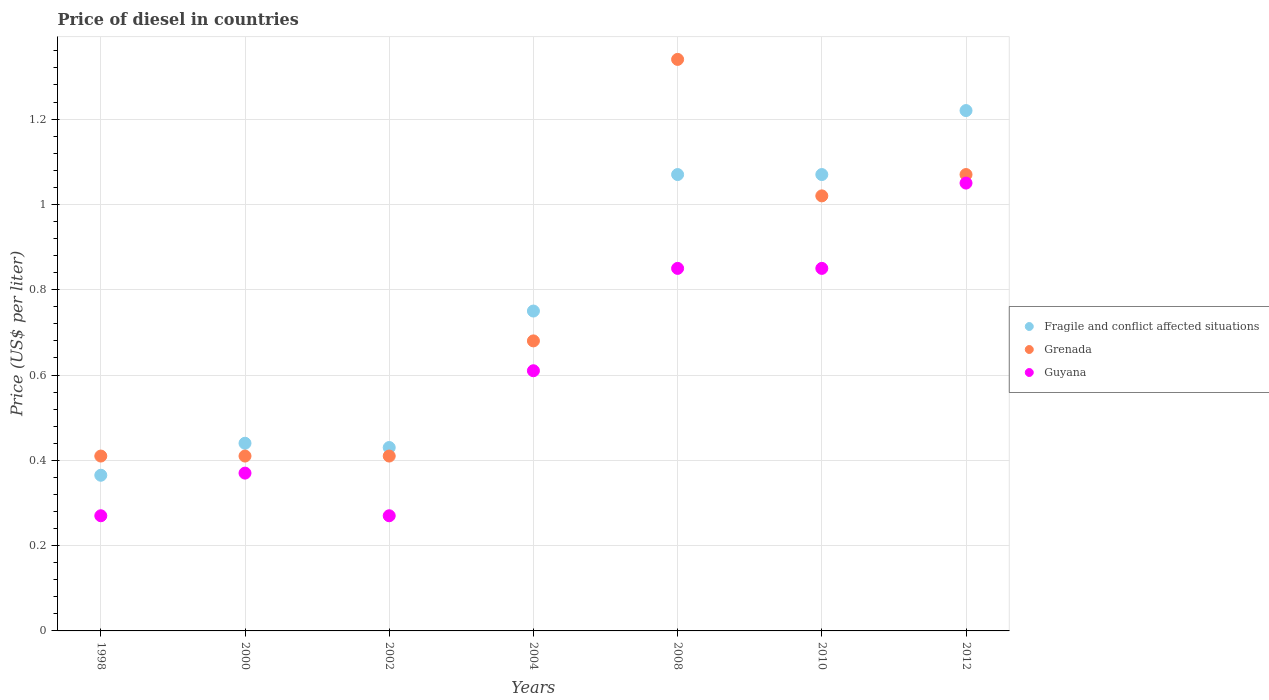Across all years, what is the minimum price of diesel in Guyana?
Provide a short and direct response. 0.27. What is the total price of diesel in Guyana in the graph?
Your response must be concise. 4.27. What is the difference between the price of diesel in Guyana in 2002 and that in 2012?
Keep it short and to the point. -0.78. What is the difference between the price of diesel in Guyana in 2000 and the price of diesel in Grenada in 2008?
Offer a very short reply. -0.97. What is the average price of diesel in Grenada per year?
Offer a very short reply. 0.76. In the year 2002, what is the difference between the price of diesel in Guyana and price of diesel in Fragile and conflict affected situations?
Offer a very short reply. -0.16. What is the ratio of the price of diesel in Fragile and conflict affected situations in 1998 to that in 2010?
Your response must be concise. 0.34. Is the difference between the price of diesel in Guyana in 1998 and 2012 greater than the difference between the price of diesel in Fragile and conflict affected situations in 1998 and 2012?
Your answer should be compact. Yes. What is the difference between the highest and the second highest price of diesel in Grenada?
Keep it short and to the point. 0.27. What is the difference between the highest and the lowest price of diesel in Fragile and conflict affected situations?
Make the answer very short. 0.85. In how many years, is the price of diesel in Grenada greater than the average price of diesel in Grenada taken over all years?
Offer a very short reply. 3. Is the sum of the price of diesel in Fragile and conflict affected situations in 2002 and 2012 greater than the maximum price of diesel in Guyana across all years?
Your answer should be compact. Yes. Is it the case that in every year, the sum of the price of diesel in Guyana and price of diesel in Fragile and conflict affected situations  is greater than the price of diesel in Grenada?
Your answer should be compact. Yes. Is the price of diesel in Fragile and conflict affected situations strictly less than the price of diesel in Guyana over the years?
Give a very brief answer. No. How many dotlines are there?
Give a very brief answer. 3. Are the values on the major ticks of Y-axis written in scientific E-notation?
Provide a succinct answer. No. Does the graph contain any zero values?
Provide a short and direct response. No. Does the graph contain grids?
Provide a succinct answer. Yes. Where does the legend appear in the graph?
Your answer should be very brief. Center right. How many legend labels are there?
Ensure brevity in your answer.  3. How are the legend labels stacked?
Your response must be concise. Vertical. What is the title of the graph?
Your answer should be very brief. Price of diesel in countries. What is the label or title of the X-axis?
Your answer should be compact. Years. What is the label or title of the Y-axis?
Your answer should be very brief. Price (US$ per liter). What is the Price (US$ per liter) of Fragile and conflict affected situations in 1998?
Ensure brevity in your answer.  0.36. What is the Price (US$ per liter) in Grenada in 1998?
Your answer should be very brief. 0.41. What is the Price (US$ per liter) in Guyana in 1998?
Offer a very short reply. 0.27. What is the Price (US$ per liter) in Fragile and conflict affected situations in 2000?
Ensure brevity in your answer.  0.44. What is the Price (US$ per liter) in Grenada in 2000?
Your answer should be very brief. 0.41. What is the Price (US$ per liter) of Guyana in 2000?
Your answer should be compact. 0.37. What is the Price (US$ per liter) of Fragile and conflict affected situations in 2002?
Make the answer very short. 0.43. What is the Price (US$ per liter) in Grenada in 2002?
Offer a very short reply. 0.41. What is the Price (US$ per liter) in Guyana in 2002?
Make the answer very short. 0.27. What is the Price (US$ per liter) in Fragile and conflict affected situations in 2004?
Your response must be concise. 0.75. What is the Price (US$ per liter) in Grenada in 2004?
Ensure brevity in your answer.  0.68. What is the Price (US$ per liter) in Guyana in 2004?
Provide a succinct answer. 0.61. What is the Price (US$ per liter) in Fragile and conflict affected situations in 2008?
Your answer should be compact. 1.07. What is the Price (US$ per liter) in Grenada in 2008?
Offer a terse response. 1.34. What is the Price (US$ per liter) of Guyana in 2008?
Keep it short and to the point. 0.85. What is the Price (US$ per liter) of Fragile and conflict affected situations in 2010?
Make the answer very short. 1.07. What is the Price (US$ per liter) in Grenada in 2010?
Offer a terse response. 1.02. What is the Price (US$ per liter) of Fragile and conflict affected situations in 2012?
Your answer should be compact. 1.22. What is the Price (US$ per liter) of Grenada in 2012?
Provide a short and direct response. 1.07. Across all years, what is the maximum Price (US$ per liter) of Fragile and conflict affected situations?
Give a very brief answer. 1.22. Across all years, what is the maximum Price (US$ per liter) of Grenada?
Ensure brevity in your answer.  1.34. Across all years, what is the maximum Price (US$ per liter) in Guyana?
Your response must be concise. 1.05. Across all years, what is the minimum Price (US$ per liter) of Fragile and conflict affected situations?
Your answer should be compact. 0.36. Across all years, what is the minimum Price (US$ per liter) of Grenada?
Your answer should be very brief. 0.41. Across all years, what is the minimum Price (US$ per liter) of Guyana?
Provide a succinct answer. 0.27. What is the total Price (US$ per liter) in Fragile and conflict affected situations in the graph?
Provide a short and direct response. 5.34. What is the total Price (US$ per liter) of Grenada in the graph?
Your answer should be compact. 5.34. What is the total Price (US$ per liter) of Guyana in the graph?
Keep it short and to the point. 4.27. What is the difference between the Price (US$ per liter) of Fragile and conflict affected situations in 1998 and that in 2000?
Offer a very short reply. -0.07. What is the difference between the Price (US$ per liter) of Guyana in 1998 and that in 2000?
Keep it short and to the point. -0.1. What is the difference between the Price (US$ per liter) of Fragile and conflict affected situations in 1998 and that in 2002?
Ensure brevity in your answer.  -0.07. What is the difference between the Price (US$ per liter) of Fragile and conflict affected situations in 1998 and that in 2004?
Give a very brief answer. -0.39. What is the difference between the Price (US$ per liter) of Grenada in 1998 and that in 2004?
Ensure brevity in your answer.  -0.27. What is the difference between the Price (US$ per liter) of Guyana in 1998 and that in 2004?
Provide a short and direct response. -0.34. What is the difference between the Price (US$ per liter) of Fragile and conflict affected situations in 1998 and that in 2008?
Ensure brevity in your answer.  -0.7. What is the difference between the Price (US$ per liter) in Grenada in 1998 and that in 2008?
Offer a very short reply. -0.93. What is the difference between the Price (US$ per liter) of Guyana in 1998 and that in 2008?
Your answer should be compact. -0.58. What is the difference between the Price (US$ per liter) of Fragile and conflict affected situations in 1998 and that in 2010?
Your response must be concise. -0.7. What is the difference between the Price (US$ per liter) of Grenada in 1998 and that in 2010?
Ensure brevity in your answer.  -0.61. What is the difference between the Price (US$ per liter) in Guyana in 1998 and that in 2010?
Provide a succinct answer. -0.58. What is the difference between the Price (US$ per liter) of Fragile and conflict affected situations in 1998 and that in 2012?
Your answer should be compact. -0.85. What is the difference between the Price (US$ per liter) of Grenada in 1998 and that in 2012?
Keep it short and to the point. -0.66. What is the difference between the Price (US$ per liter) in Guyana in 1998 and that in 2012?
Give a very brief answer. -0.78. What is the difference between the Price (US$ per liter) in Fragile and conflict affected situations in 2000 and that in 2002?
Ensure brevity in your answer.  0.01. What is the difference between the Price (US$ per liter) in Guyana in 2000 and that in 2002?
Your answer should be compact. 0.1. What is the difference between the Price (US$ per liter) of Fragile and conflict affected situations in 2000 and that in 2004?
Offer a very short reply. -0.31. What is the difference between the Price (US$ per liter) in Grenada in 2000 and that in 2004?
Ensure brevity in your answer.  -0.27. What is the difference between the Price (US$ per liter) of Guyana in 2000 and that in 2004?
Your answer should be very brief. -0.24. What is the difference between the Price (US$ per liter) of Fragile and conflict affected situations in 2000 and that in 2008?
Give a very brief answer. -0.63. What is the difference between the Price (US$ per liter) of Grenada in 2000 and that in 2008?
Give a very brief answer. -0.93. What is the difference between the Price (US$ per liter) in Guyana in 2000 and that in 2008?
Your answer should be compact. -0.48. What is the difference between the Price (US$ per liter) of Fragile and conflict affected situations in 2000 and that in 2010?
Offer a terse response. -0.63. What is the difference between the Price (US$ per liter) in Grenada in 2000 and that in 2010?
Ensure brevity in your answer.  -0.61. What is the difference between the Price (US$ per liter) in Guyana in 2000 and that in 2010?
Keep it short and to the point. -0.48. What is the difference between the Price (US$ per liter) in Fragile and conflict affected situations in 2000 and that in 2012?
Your answer should be compact. -0.78. What is the difference between the Price (US$ per liter) in Grenada in 2000 and that in 2012?
Provide a succinct answer. -0.66. What is the difference between the Price (US$ per liter) of Guyana in 2000 and that in 2012?
Provide a short and direct response. -0.68. What is the difference between the Price (US$ per liter) in Fragile and conflict affected situations in 2002 and that in 2004?
Provide a succinct answer. -0.32. What is the difference between the Price (US$ per liter) of Grenada in 2002 and that in 2004?
Your response must be concise. -0.27. What is the difference between the Price (US$ per liter) of Guyana in 2002 and that in 2004?
Offer a very short reply. -0.34. What is the difference between the Price (US$ per liter) in Fragile and conflict affected situations in 2002 and that in 2008?
Ensure brevity in your answer.  -0.64. What is the difference between the Price (US$ per liter) of Grenada in 2002 and that in 2008?
Keep it short and to the point. -0.93. What is the difference between the Price (US$ per liter) in Guyana in 2002 and that in 2008?
Offer a very short reply. -0.58. What is the difference between the Price (US$ per liter) of Fragile and conflict affected situations in 2002 and that in 2010?
Make the answer very short. -0.64. What is the difference between the Price (US$ per liter) of Grenada in 2002 and that in 2010?
Your response must be concise. -0.61. What is the difference between the Price (US$ per liter) in Guyana in 2002 and that in 2010?
Your response must be concise. -0.58. What is the difference between the Price (US$ per liter) in Fragile and conflict affected situations in 2002 and that in 2012?
Provide a succinct answer. -0.79. What is the difference between the Price (US$ per liter) in Grenada in 2002 and that in 2012?
Give a very brief answer. -0.66. What is the difference between the Price (US$ per liter) of Guyana in 2002 and that in 2012?
Provide a short and direct response. -0.78. What is the difference between the Price (US$ per liter) in Fragile and conflict affected situations in 2004 and that in 2008?
Provide a succinct answer. -0.32. What is the difference between the Price (US$ per liter) in Grenada in 2004 and that in 2008?
Give a very brief answer. -0.66. What is the difference between the Price (US$ per liter) in Guyana in 2004 and that in 2008?
Make the answer very short. -0.24. What is the difference between the Price (US$ per liter) in Fragile and conflict affected situations in 2004 and that in 2010?
Make the answer very short. -0.32. What is the difference between the Price (US$ per liter) in Grenada in 2004 and that in 2010?
Offer a terse response. -0.34. What is the difference between the Price (US$ per liter) in Guyana in 2004 and that in 2010?
Keep it short and to the point. -0.24. What is the difference between the Price (US$ per liter) of Fragile and conflict affected situations in 2004 and that in 2012?
Offer a terse response. -0.47. What is the difference between the Price (US$ per liter) of Grenada in 2004 and that in 2012?
Make the answer very short. -0.39. What is the difference between the Price (US$ per liter) in Guyana in 2004 and that in 2012?
Your answer should be very brief. -0.44. What is the difference between the Price (US$ per liter) of Fragile and conflict affected situations in 2008 and that in 2010?
Provide a short and direct response. 0. What is the difference between the Price (US$ per liter) of Grenada in 2008 and that in 2010?
Make the answer very short. 0.32. What is the difference between the Price (US$ per liter) in Fragile and conflict affected situations in 2008 and that in 2012?
Make the answer very short. -0.15. What is the difference between the Price (US$ per liter) of Grenada in 2008 and that in 2012?
Ensure brevity in your answer.  0.27. What is the difference between the Price (US$ per liter) in Guyana in 2008 and that in 2012?
Your answer should be very brief. -0.2. What is the difference between the Price (US$ per liter) of Grenada in 2010 and that in 2012?
Provide a succinct answer. -0.05. What is the difference between the Price (US$ per liter) in Fragile and conflict affected situations in 1998 and the Price (US$ per liter) in Grenada in 2000?
Provide a short and direct response. -0.04. What is the difference between the Price (US$ per liter) of Fragile and conflict affected situations in 1998 and the Price (US$ per liter) of Guyana in 2000?
Provide a short and direct response. -0.01. What is the difference between the Price (US$ per liter) of Fragile and conflict affected situations in 1998 and the Price (US$ per liter) of Grenada in 2002?
Your answer should be very brief. -0.04. What is the difference between the Price (US$ per liter) of Fragile and conflict affected situations in 1998 and the Price (US$ per liter) of Guyana in 2002?
Your answer should be very brief. 0.1. What is the difference between the Price (US$ per liter) of Grenada in 1998 and the Price (US$ per liter) of Guyana in 2002?
Ensure brevity in your answer.  0.14. What is the difference between the Price (US$ per liter) in Fragile and conflict affected situations in 1998 and the Price (US$ per liter) in Grenada in 2004?
Make the answer very short. -0.32. What is the difference between the Price (US$ per liter) in Fragile and conflict affected situations in 1998 and the Price (US$ per liter) in Guyana in 2004?
Provide a succinct answer. -0.24. What is the difference between the Price (US$ per liter) in Grenada in 1998 and the Price (US$ per liter) in Guyana in 2004?
Offer a terse response. -0.2. What is the difference between the Price (US$ per liter) of Fragile and conflict affected situations in 1998 and the Price (US$ per liter) of Grenada in 2008?
Your answer should be compact. -0.97. What is the difference between the Price (US$ per liter) of Fragile and conflict affected situations in 1998 and the Price (US$ per liter) of Guyana in 2008?
Your answer should be compact. -0.48. What is the difference between the Price (US$ per liter) of Grenada in 1998 and the Price (US$ per liter) of Guyana in 2008?
Provide a succinct answer. -0.44. What is the difference between the Price (US$ per liter) in Fragile and conflict affected situations in 1998 and the Price (US$ per liter) in Grenada in 2010?
Your answer should be compact. -0.66. What is the difference between the Price (US$ per liter) in Fragile and conflict affected situations in 1998 and the Price (US$ per liter) in Guyana in 2010?
Offer a very short reply. -0.48. What is the difference between the Price (US$ per liter) in Grenada in 1998 and the Price (US$ per liter) in Guyana in 2010?
Offer a very short reply. -0.44. What is the difference between the Price (US$ per liter) of Fragile and conflict affected situations in 1998 and the Price (US$ per liter) of Grenada in 2012?
Your response must be concise. -0.7. What is the difference between the Price (US$ per liter) of Fragile and conflict affected situations in 1998 and the Price (US$ per liter) of Guyana in 2012?
Your answer should be compact. -0.69. What is the difference between the Price (US$ per liter) of Grenada in 1998 and the Price (US$ per liter) of Guyana in 2012?
Make the answer very short. -0.64. What is the difference between the Price (US$ per liter) in Fragile and conflict affected situations in 2000 and the Price (US$ per liter) in Grenada in 2002?
Offer a terse response. 0.03. What is the difference between the Price (US$ per liter) of Fragile and conflict affected situations in 2000 and the Price (US$ per liter) of Guyana in 2002?
Keep it short and to the point. 0.17. What is the difference between the Price (US$ per liter) of Grenada in 2000 and the Price (US$ per liter) of Guyana in 2002?
Your response must be concise. 0.14. What is the difference between the Price (US$ per liter) in Fragile and conflict affected situations in 2000 and the Price (US$ per liter) in Grenada in 2004?
Your answer should be compact. -0.24. What is the difference between the Price (US$ per liter) in Fragile and conflict affected situations in 2000 and the Price (US$ per liter) in Guyana in 2004?
Your response must be concise. -0.17. What is the difference between the Price (US$ per liter) in Fragile and conflict affected situations in 2000 and the Price (US$ per liter) in Guyana in 2008?
Provide a succinct answer. -0.41. What is the difference between the Price (US$ per liter) of Grenada in 2000 and the Price (US$ per liter) of Guyana in 2008?
Your answer should be compact. -0.44. What is the difference between the Price (US$ per liter) of Fragile and conflict affected situations in 2000 and the Price (US$ per liter) of Grenada in 2010?
Your answer should be very brief. -0.58. What is the difference between the Price (US$ per liter) of Fragile and conflict affected situations in 2000 and the Price (US$ per liter) of Guyana in 2010?
Provide a succinct answer. -0.41. What is the difference between the Price (US$ per liter) of Grenada in 2000 and the Price (US$ per liter) of Guyana in 2010?
Give a very brief answer. -0.44. What is the difference between the Price (US$ per liter) of Fragile and conflict affected situations in 2000 and the Price (US$ per liter) of Grenada in 2012?
Your answer should be compact. -0.63. What is the difference between the Price (US$ per liter) in Fragile and conflict affected situations in 2000 and the Price (US$ per liter) in Guyana in 2012?
Provide a succinct answer. -0.61. What is the difference between the Price (US$ per liter) in Grenada in 2000 and the Price (US$ per liter) in Guyana in 2012?
Make the answer very short. -0.64. What is the difference between the Price (US$ per liter) of Fragile and conflict affected situations in 2002 and the Price (US$ per liter) of Guyana in 2004?
Make the answer very short. -0.18. What is the difference between the Price (US$ per liter) in Fragile and conflict affected situations in 2002 and the Price (US$ per liter) in Grenada in 2008?
Ensure brevity in your answer.  -0.91. What is the difference between the Price (US$ per liter) in Fragile and conflict affected situations in 2002 and the Price (US$ per liter) in Guyana in 2008?
Your answer should be very brief. -0.42. What is the difference between the Price (US$ per liter) of Grenada in 2002 and the Price (US$ per liter) of Guyana in 2008?
Your answer should be very brief. -0.44. What is the difference between the Price (US$ per liter) of Fragile and conflict affected situations in 2002 and the Price (US$ per liter) of Grenada in 2010?
Make the answer very short. -0.59. What is the difference between the Price (US$ per liter) in Fragile and conflict affected situations in 2002 and the Price (US$ per liter) in Guyana in 2010?
Give a very brief answer. -0.42. What is the difference between the Price (US$ per liter) in Grenada in 2002 and the Price (US$ per liter) in Guyana in 2010?
Keep it short and to the point. -0.44. What is the difference between the Price (US$ per liter) of Fragile and conflict affected situations in 2002 and the Price (US$ per liter) of Grenada in 2012?
Your response must be concise. -0.64. What is the difference between the Price (US$ per liter) in Fragile and conflict affected situations in 2002 and the Price (US$ per liter) in Guyana in 2012?
Offer a terse response. -0.62. What is the difference between the Price (US$ per liter) in Grenada in 2002 and the Price (US$ per liter) in Guyana in 2012?
Your answer should be compact. -0.64. What is the difference between the Price (US$ per liter) in Fragile and conflict affected situations in 2004 and the Price (US$ per liter) in Grenada in 2008?
Ensure brevity in your answer.  -0.59. What is the difference between the Price (US$ per liter) in Fragile and conflict affected situations in 2004 and the Price (US$ per liter) in Guyana in 2008?
Your response must be concise. -0.1. What is the difference between the Price (US$ per liter) of Grenada in 2004 and the Price (US$ per liter) of Guyana in 2008?
Your answer should be compact. -0.17. What is the difference between the Price (US$ per liter) in Fragile and conflict affected situations in 2004 and the Price (US$ per liter) in Grenada in 2010?
Keep it short and to the point. -0.27. What is the difference between the Price (US$ per liter) of Grenada in 2004 and the Price (US$ per liter) of Guyana in 2010?
Offer a very short reply. -0.17. What is the difference between the Price (US$ per liter) in Fragile and conflict affected situations in 2004 and the Price (US$ per liter) in Grenada in 2012?
Your response must be concise. -0.32. What is the difference between the Price (US$ per liter) in Grenada in 2004 and the Price (US$ per liter) in Guyana in 2012?
Ensure brevity in your answer.  -0.37. What is the difference between the Price (US$ per liter) in Fragile and conflict affected situations in 2008 and the Price (US$ per liter) in Grenada in 2010?
Make the answer very short. 0.05. What is the difference between the Price (US$ per liter) in Fragile and conflict affected situations in 2008 and the Price (US$ per liter) in Guyana in 2010?
Your answer should be very brief. 0.22. What is the difference between the Price (US$ per liter) of Grenada in 2008 and the Price (US$ per liter) of Guyana in 2010?
Give a very brief answer. 0.49. What is the difference between the Price (US$ per liter) in Grenada in 2008 and the Price (US$ per liter) in Guyana in 2012?
Your response must be concise. 0.29. What is the difference between the Price (US$ per liter) of Grenada in 2010 and the Price (US$ per liter) of Guyana in 2012?
Keep it short and to the point. -0.03. What is the average Price (US$ per liter) of Fragile and conflict affected situations per year?
Provide a short and direct response. 0.76. What is the average Price (US$ per liter) in Grenada per year?
Provide a short and direct response. 0.76. What is the average Price (US$ per liter) of Guyana per year?
Ensure brevity in your answer.  0.61. In the year 1998, what is the difference between the Price (US$ per liter) of Fragile and conflict affected situations and Price (US$ per liter) of Grenada?
Offer a terse response. -0.04. In the year 1998, what is the difference between the Price (US$ per liter) in Fragile and conflict affected situations and Price (US$ per liter) in Guyana?
Give a very brief answer. 0.1. In the year 1998, what is the difference between the Price (US$ per liter) of Grenada and Price (US$ per liter) of Guyana?
Offer a very short reply. 0.14. In the year 2000, what is the difference between the Price (US$ per liter) of Fragile and conflict affected situations and Price (US$ per liter) of Grenada?
Offer a terse response. 0.03. In the year 2000, what is the difference between the Price (US$ per liter) in Fragile and conflict affected situations and Price (US$ per liter) in Guyana?
Make the answer very short. 0.07. In the year 2000, what is the difference between the Price (US$ per liter) of Grenada and Price (US$ per liter) of Guyana?
Your answer should be very brief. 0.04. In the year 2002, what is the difference between the Price (US$ per liter) of Fragile and conflict affected situations and Price (US$ per liter) of Grenada?
Provide a short and direct response. 0.02. In the year 2002, what is the difference between the Price (US$ per liter) in Fragile and conflict affected situations and Price (US$ per liter) in Guyana?
Offer a very short reply. 0.16. In the year 2002, what is the difference between the Price (US$ per liter) in Grenada and Price (US$ per liter) in Guyana?
Provide a short and direct response. 0.14. In the year 2004, what is the difference between the Price (US$ per liter) in Fragile and conflict affected situations and Price (US$ per liter) in Grenada?
Provide a succinct answer. 0.07. In the year 2004, what is the difference between the Price (US$ per liter) in Fragile and conflict affected situations and Price (US$ per liter) in Guyana?
Your answer should be very brief. 0.14. In the year 2004, what is the difference between the Price (US$ per liter) of Grenada and Price (US$ per liter) of Guyana?
Provide a short and direct response. 0.07. In the year 2008, what is the difference between the Price (US$ per liter) of Fragile and conflict affected situations and Price (US$ per liter) of Grenada?
Ensure brevity in your answer.  -0.27. In the year 2008, what is the difference between the Price (US$ per liter) in Fragile and conflict affected situations and Price (US$ per liter) in Guyana?
Provide a short and direct response. 0.22. In the year 2008, what is the difference between the Price (US$ per liter) in Grenada and Price (US$ per liter) in Guyana?
Offer a very short reply. 0.49. In the year 2010, what is the difference between the Price (US$ per liter) in Fragile and conflict affected situations and Price (US$ per liter) in Grenada?
Offer a terse response. 0.05. In the year 2010, what is the difference between the Price (US$ per liter) in Fragile and conflict affected situations and Price (US$ per liter) in Guyana?
Give a very brief answer. 0.22. In the year 2010, what is the difference between the Price (US$ per liter) of Grenada and Price (US$ per liter) of Guyana?
Offer a very short reply. 0.17. In the year 2012, what is the difference between the Price (US$ per liter) in Fragile and conflict affected situations and Price (US$ per liter) in Guyana?
Your answer should be compact. 0.17. What is the ratio of the Price (US$ per liter) in Fragile and conflict affected situations in 1998 to that in 2000?
Your response must be concise. 0.83. What is the ratio of the Price (US$ per liter) of Guyana in 1998 to that in 2000?
Ensure brevity in your answer.  0.73. What is the ratio of the Price (US$ per liter) of Fragile and conflict affected situations in 1998 to that in 2002?
Your answer should be very brief. 0.85. What is the ratio of the Price (US$ per liter) in Fragile and conflict affected situations in 1998 to that in 2004?
Provide a succinct answer. 0.49. What is the ratio of the Price (US$ per liter) of Grenada in 1998 to that in 2004?
Your response must be concise. 0.6. What is the ratio of the Price (US$ per liter) in Guyana in 1998 to that in 2004?
Make the answer very short. 0.44. What is the ratio of the Price (US$ per liter) of Fragile and conflict affected situations in 1998 to that in 2008?
Provide a succinct answer. 0.34. What is the ratio of the Price (US$ per liter) of Grenada in 1998 to that in 2008?
Make the answer very short. 0.31. What is the ratio of the Price (US$ per liter) in Guyana in 1998 to that in 2008?
Keep it short and to the point. 0.32. What is the ratio of the Price (US$ per liter) of Fragile and conflict affected situations in 1998 to that in 2010?
Offer a terse response. 0.34. What is the ratio of the Price (US$ per liter) in Grenada in 1998 to that in 2010?
Make the answer very short. 0.4. What is the ratio of the Price (US$ per liter) of Guyana in 1998 to that in 2010?
Give a very brief answer. 0.32. What is the ratio of the Price (US$ per liter) of Fragile and conflict affected situations in 1998 to that in 2012?
Offer a terse response. 0.3. What is the ratio of the Price (US$ per liter) of Grenada in 1998 to that in 2012?
Provide a succinct answer. 0.38. What is the ratio of the Price (US$ per liter) in Guyana in 1998 to that in 2012?
Provide a succinct answer. 0.26. What is the ratio of the Price (US$ per liter) in Fragile and conflict affected situations in 2000 to that in 2002?
Provide a short and direct response. 1.02. What is the ratio of the Price (US$ per liter) in Grenada in 2000 to that in 2002?
Your answer should be very brief. 1. What is the ratio of the Price (US$ per liter) in Guyana in 2000 to that in 2002?
Make the answer very short. 1.37. What is the ratio of the Price (US$ per liter) of Fragile and conflict affected situations in 2000 to that in 2004?
Make the answer very short. 0.59. What is the ratio of the Price (US$ per liter) of Grenada in 2000 to that in 2004?
Offer a terse response. 0.6. What is the ratio of the Price (US$ per liter) in Guyana in 2000 to that in 2004?
Provide a succinct answer. 0.61. What is the ratio of the Price (US$ per liter) in Fragile and conflict affected situations in 2000 to that in 2008?
Your answer should be very brief. 0.41. What is the ratio of the Price (US$ per liter) of Grenada in 2000 to that in 2008?
Make the answer very short. 0.31. What is the ratio of the Price (US$ per liter) of Guyana in 2000 to that in 2008?
Ensure brevity in your answer.  0.44. What is the ratio of the Price (US$ per liter) in Fragile and conflict affected situations in 2000 to that in 2010?
Offer a very short reply. 0.41. What is the ratio of the Price (US$ per liter) in Grenada in 2000 to that in 2010?
Your answer should be compact. 0.4. What is the ratio of the Price (US$ per liter) in Guyana in 2000 to that in 2010?
Give a very brief answer. 0.44. What is the ratio of the Price (US$ per liter) of Fragile and conflict affected situations in 2000 to that in 2012?
Your answer should be compact. 0.36. What is the ratio of the Price (US$ per liter) of Grenada in 2000 to that in 2012?
Make the answer very short. 0.38. What is the ratio of the Price (US$ per liter) in Guyana in 2000 to that in 2012?
Provide a succinct answer. 0.35. What is the ratio of the Price (US$ per liter) in Fragile and conflict affected situations in 2002 to that in 2004?
Keep it short and to the point. 0.57. What is the ratio of the Price (US$ per liter) in Grenada in 2002 to that in 2004?
Provide a short and direct response. 0.6. What is the ratio of the Price (US$ per liter) of Guyana in 2002 to that in 2004?
Your answer should be very brief. 0.44. What is the ratio of the Price (US$ per liter) in Fragile and conflict affected situations in 2002 to that in 2008?
Your response must be concise. 0.4. What is the ratio of the Price (US$ per liter) in Grenada in 2002 to that in 2008?
Keep it short and to the point. 0.31. What is the ratio of the Price (US$ per liter) in Guyana in 2002 to that in 2008?
Keep it short and to the point. 0.32. What is the ratio of the Price (US$ per liter) of Fragile and conflict affected situations in 2002 to that in 2010?
Your answer should be compact. 0.4. What is the ratio of the Price (US$ per liter) in Grenada in 2002 to that in 2010?
Offer a terse response. 0.4. What is the ratio of the Price (US$ per liter) of Guyana in 2002 to that in 2010?
Offer a terse response. 0.32. What is the ratio of the Price (US$ per liter) of Fragile and conflict affected situations in 2002 to that in 2012?
Provide a short and direct response. 0.35. What is the ratio of the Price (US$ per liter) of Grenada in 2002 to that in 2012?
Make the answer very short. 0.38. What is the ratio of the Price (US$ per liter) of Guyana in 2002 to that in 2012?
Keep it short and to the point. 0.26. What is the ratio of the Price (US$ per liter) of Fragile and conflict affected situations in 2004 to that in 2008?
Make the answer very short. 0.7. What is the ratio of the Price (US$ per liter) in Grenada in 2004 to that in 2008?
Provide a short and direct response. 0.51. What is the ratio of the Price (US$ per liter) of Guyana in 2004 to that in 2008?
Provide a short and direct response. 0.72. What is the ratio of the Price (US$ per liter) of Fragile and conflict affected situations in 2004 to that in 2010?
Give a very brief answer. 0.7. What is the ratio of the Price (US$ per liter) in Grenada in 2004 to that in 2010?
Give a very brief answer. 0.67. What is the ratio of the Price (US$ per liter) of Guyana in 2004 to that in 2010?
Offer a terse response. 0.72. What is the ratio of the Price (US$ per liter) in Fragile and conflict affected situations in 2004 to that in 2012?
Your answer should be very brief. 0.61. What is the ratio of the Price (US$ per liter) of Grenada in 2004 to that in 2012?
Your answer should be very brief. 0.64. What is the ratio of the Price (US$ per liter) in Guyana in 2004 to that in 2012?
Keep it short and to the point. 0.58. What is the ratio of the Price (US$ per liter) of Fragile and conflict affected situations in 2008 to that in 2010?
Provide a succinct answer. 1. What is the ratio of the Price (US$ per liter) of Grenada in 2008 to that in 2010?
Your answer should be compact. 1.31. What is the ratio of the Price (US$ per liter) of Guyana in 2008 to that in 2010?
Make the answer very short. 1. What is the ratio of the Price (US$ per liter) of Fragile and conflict affected situations in 2008 to that in 2012?
Your answer should be compact. 0.88. What is the ratio of the Price (US$ per liter) of Grenada in 2008 to that in 2012?
Keep it short and to the point. 1.25. What is the ratio of the Price (US$ per liter) in Guyana in 2008 to that in 2012?
Your answer should be very brief. 0.81. What is the ratio of the Price (US$ per liter) in Fragile and conflict affected situations in 2010 to that in 2012?
Offer a very short reply. 0.88. What is the ratio of the Price (US$ per liter) of Grenada in 2010 to that in 2012?
Your answer should be very brief. 0.95. What is the ratio of the Price (US$ per liter) of Guyana in 2010 to that in 2012?
Give a very brief answer. 0.81. What is the difference between the highest and the second highest Price (US$ per liter) of Grenada?
Keep it short and to the point. 0.27. What is the difference between the highest and the second highest Price (US$ per liter) of Guyana?
Your response must be concise. 0.2. What is the difference between the highest and the lowest Price (US$ per liter) of Fragile and conflict affected situations?
Keep it short and to the point. 0.85. What is the difference between the highest and the lowest Price (US$ per liter) of Grenada?
Give a very brief answer. 0.93. What is the difference between the highest and the lowest Price (US$ per liter) in Guyana?
Keep it short and to the point. 0.78. 